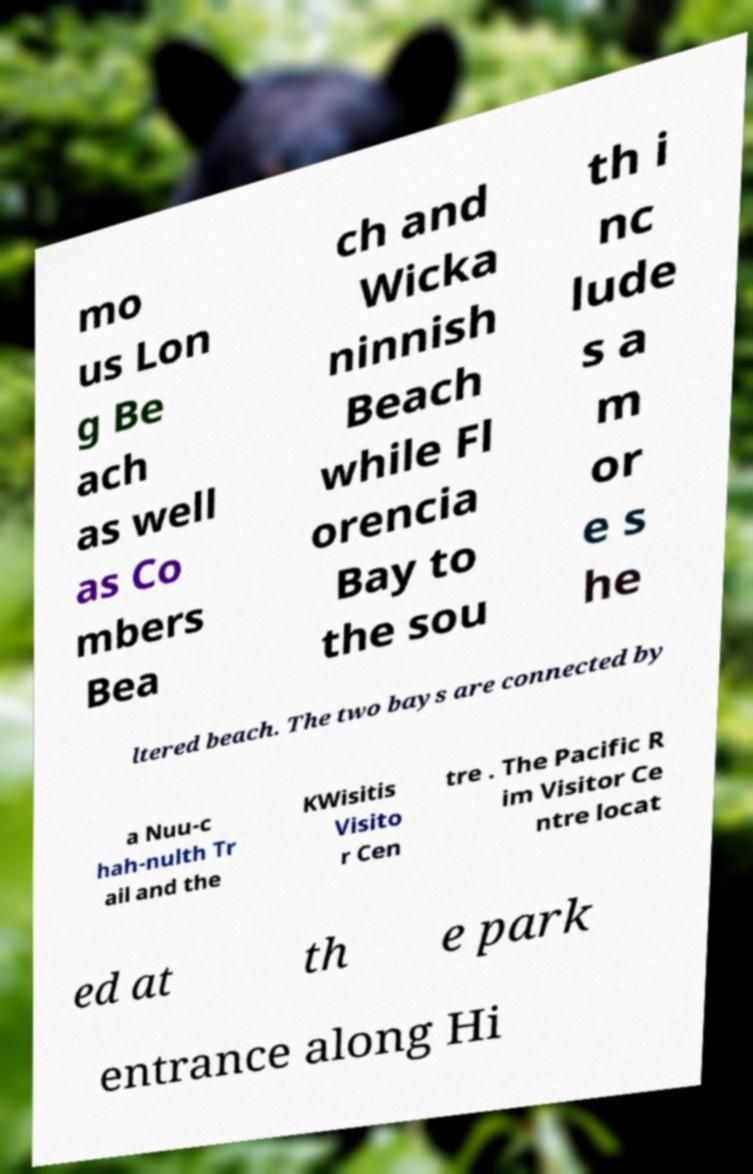There's text embedded in this image that I need extracted. Can you transcribe it verbatim? mo us Lon g Be ach as well as Co mbers Bea ch and Wicka ninnish Beach while Fl orencia Bay to the sou th i nc lude s a m or e s he ltered beach. The two bays are connected by a Nuu-c hah-nulth Tr ail and the KWisitis Visito r Cen tre . The Pacific R im Visitor Ce ntre locat ed at th e park entrance along Hi 